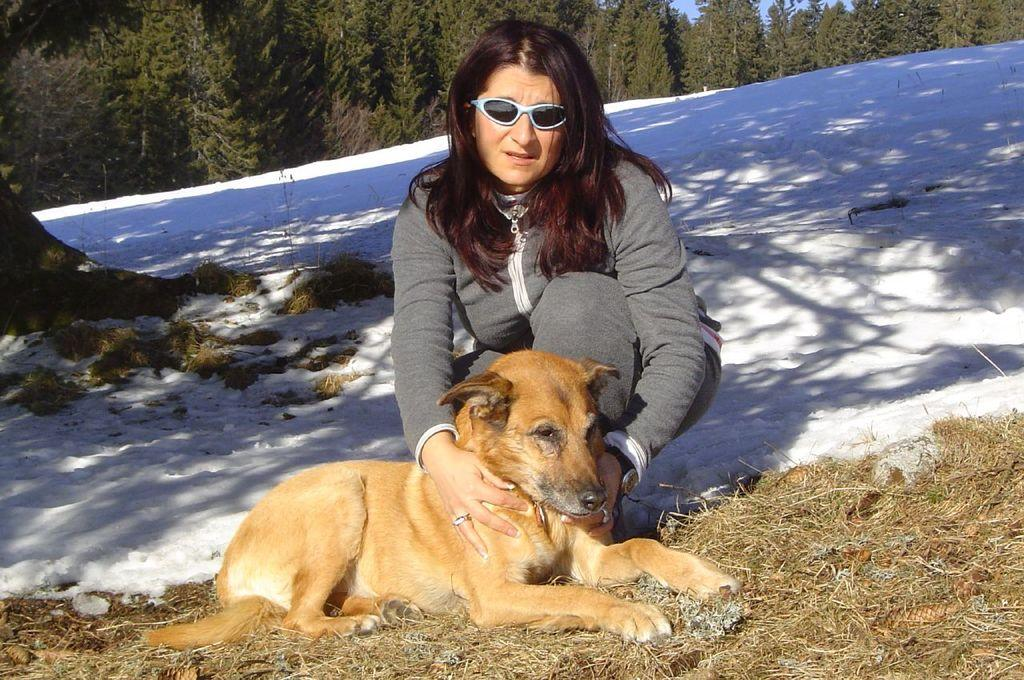What is the main subject of the image? There is a lady in the image. What is the lady wearing in the image? The lady is wearing spectacles in the image. What is the lady holding in the image? The lady is holding a dog in the image. Where is the dog located in the image? The dog is on the dry grass floor in the image. What can be seen in the background of the image? There is snow on the floor, plants, and trees in the background of the image. What type of maid is present in the image? There is no maid present in the image. What is the cook preparing in the image? There is no cook or food preparation visible in the image. 